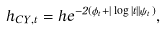<formula> <loc_0><loc_0><loc_500><loc_500>h _ { C Y , t } = h e ^ { - 2 ( \phi _ { t } + | \log | t | | \psi _ { t } ) } ,</formula> 